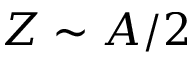<formula> <loc_0><loc_0><loc_500><loc_500>Z \sim A / 2</formula> 